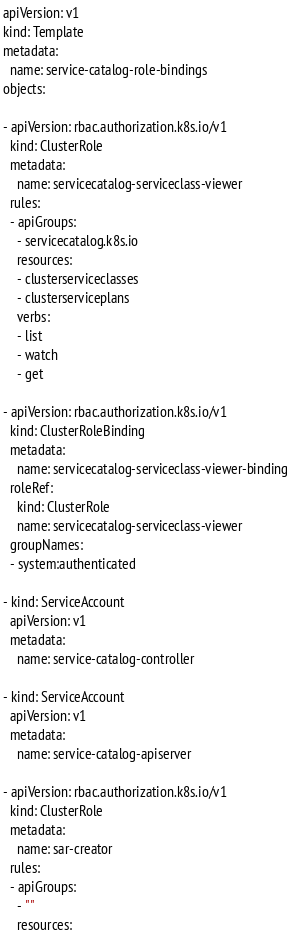Convert code to text. <code><loc_0><loc_0><loc_500><loc_500><_YAML_>apiVersion: v1
kind: Template
metadata:
  name: service-catalog-role-bindings
objects:

- apiVersion: rbac.authorization.k8s.io/v1
  kind: ClusterRole
  metadata:
    name: servicecatalog-serviceclass-viewer
  rules:
  - apiGroups:
    - servicecatalog.k8s.io
    resources:
    - clusterserviceclasses
    - clusterserviceplans
    verbs:
    - list
    - watch
    - get

- apiVersion: rbac.authorization.k8s.io/v1
  kind: ClusterRoleBinding
  metadata:
    name: servicecatalog-serviceclass-viewer-binding
  roleRef:
    kind: ClusterRole
    name: servicecatalog-serviceclass-viewer
  groupNames:
  - system:authenticated

- kind: ServiceAccount
  apiVersion: v1
  metadata:
    name: service-catalog-controller

- kind: ServiceAccount
  apiVersion: v1
  metadata:
    name: service-catalog-apiserver

- apiVersion: rbac.authorization.k8s.io/v1
  kind: ClusterRole
  metadata:
    name: sar-creator
  rules:
  - apiGroups:
    - ""
    resources:</code> 